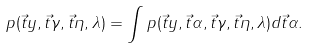Convert formula to latex. <formula><loc_0><loc_0><loc_500><loc_500>p ( \vec { t } { y } , \vec { t } { \gamma } , \vec { t } { \eta } , \lambda ) = \int p ( \vec { t } { y } , \vec { t } { \alpha } , \vec { t } { \gamma } , \vec { t } { \eta } , \lambda ) d \vec { t } { \alpha } .</formula> 